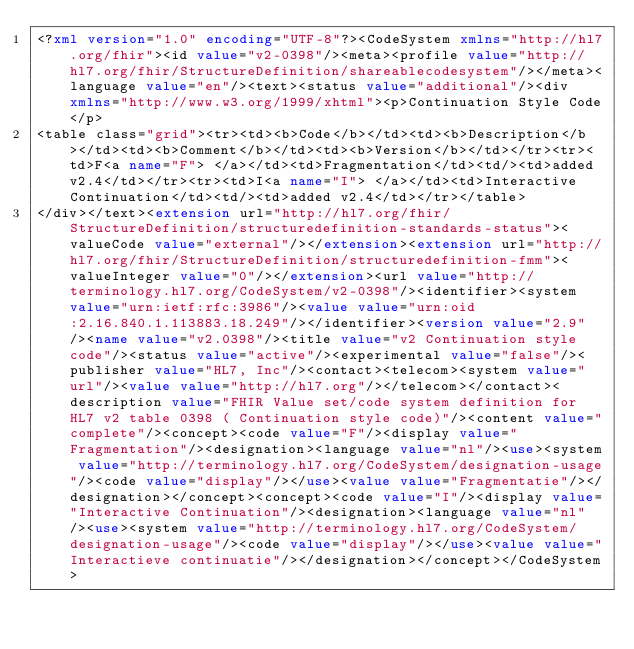<code> <loc_0><loc_0><loc_500><loc_500><_XML_><?xml version="1.0" encoding="UTF-8"?><CodeSystem xmlns="http://hl7.org/fhir"><id value="v2-0398"/><meta><profile value="http://hl7.org/fhir/StructureDefinition/shareablecodesystem"/></meta><language value="en"/><text><status value="additional"/><div xmlns="http://www.w3.org/1999/xhtml"><p>Continuation Style Code</p>
<table class="grid"><tr><td><b>Code</b></td><td><b>Description</b></td><td><b>Comment</b></td><td><b>Version</b></td></tr><tr><td>F<a name="F"> </a></td><td>Fragmentation</td><td/><td>added v2.4</td></tr><tr><td>I<a name="I"> </a></td><td>Interactive Continuation</td><td/><td>added v2.4</td></tr></table>
</div></text><extension url="http://hl7.org/fhir/StructureDefinition/structuredefinition-standards-status"><valueCode value="external"/></extension><extension url="http://hl7.org/fhir/StructureDefinition/structuredefinition-fmm"><valueInteger value="0"/></extension><url value="http://terminology.hl7.org/CodeSystem/v2-0398"/><identifier><system value="urn:ietf:rfc:3986"/><value value="urn:oid:2.16.840.1.113883.18.249"/></identifier><version value="2.9"/><name value="v2.0398"/><title value="v2 Continuation style code"/><status value="active"/><experimental value="false"/><publisher value="HL7, Inc"/><contact><telecom><system value="url"/><value value="http://hl7.org"/></telecom></contact><description value="FHIR Value set/code system definition for HL7 v2 table 0398 ( Continuation style code)"/><content value="complete"/><concept><code value="F"/><display value="Fragmentation"/><designation><language value="nl"/><use><system value="http://terminology.hl7.org/CodeSystem/designation-usage"/><code value="display"/></use><value value="Fragmentatie"/></designation></concept><concept><code value="I"/><display value="Interactive Continuation"/><designation><language value="nl"/><use><system value="http://terminology.hl7.org/CodeSystem/designation-usage"/><code value="display"/></use><value value="Interactieve continuatie"/></designation></concept></CodeSystem></code> 